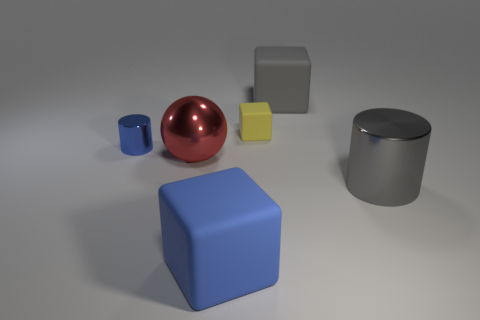Add 2 large brown matte cylinders. How many objects exist? 8 Subtract all cylinders. How many objects are left? 4 Subtract all big brown blocks. Subtract all large blue cubes. How many objects are left? 5 Add 2 tiny blue cylinders. How many tiny blue cylinders are left? 3 Add 5 small brown metal blocks. How many small brown metal blocks exist? 5 Subtract 0 yellow spheres. How many objects are left? 6 